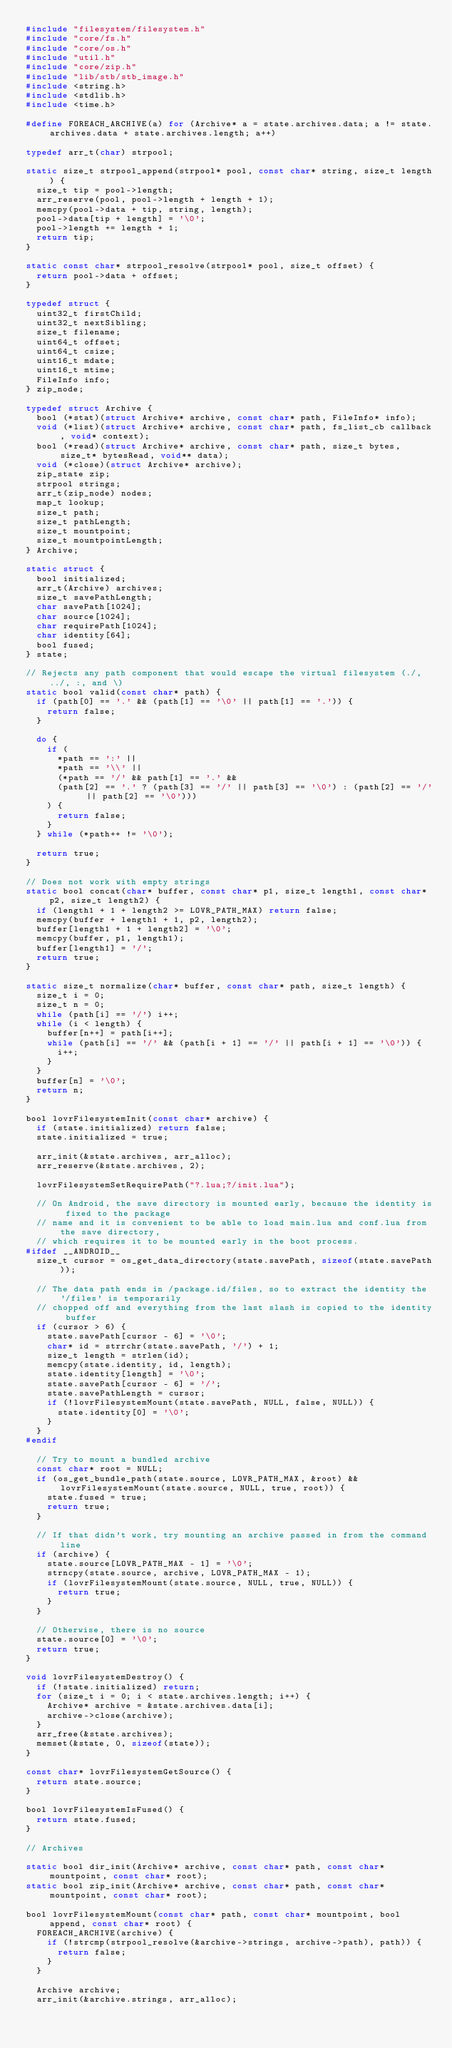<code> <loc_0><loc_0><loc_500><loc_500><_C_>#include "filesystem/filesystem.h"
#include "core/fs.h"
#include "core/os.h"
#include "util.h"
#include "core/zip.h"
#include "lib/stb/stb_image.h"
#include <string.h>
#include <stdlib.h>
#include <time.h>

#define FOREACH_ARCHIVE(a) for (Archive* a = state.archives.data; a != state.archives.data + state.archives.length; a++)

typedef arr_t(char) strpool;

static size_t strpool_append(strpool* pool, const char* string, size_t length) {
  size_t tip = pool->length;
  arr_reserve(pool, pool->length + length + 1);
  memcpy(pool->data + tip, string, length);
  pool->data[tip + length] = '\0';
  pool->length += length + 1;
  return tip;
}

static const char* strpool_resolve(strpool* pool, size_t offset) {
  return pool->data + offset;
}

typedef struct {
  uint32_t firstChild;
  uint32_t nextSibling;
  size_t filename;
  uint64_t offset;
  uint64_t csize;
  uint16_t mdate;
  uint16_t mtime;
  FileInfo info;
} zip_node;

typedef struct Archive {
  bool (*stat)(struct Archive* archive, const char* path, FileInfo* info);
  void (*list)(struct Archive* archive, const char* path, fs_list_cb callback, void* context);
  bool (*read)(struct Archive* archive, const char* path, size_t bytes, size_t* bytesRead, void** data);
  void (*close)(struct Archive* archive);
  zip_state zip;
  strpool strings;
  arr_t(zip_node) nodes;
  map_t lookup;
  size_t path;
  size_t pathLength;
  size_t mountpoint;
  size_t mountpointLength;
} Archive;

static struct {
  bool initialized;
  arr_t(Archive) archives;
  size_t savePathLength;
  char savePath[1024];
  char source[1024];
  char requirePath[1024];
  char identity[64];
  bool fused;
} state;

// Rejects any path component that would escape the virtual filesystem (./, ../, :, and \)
static bool valid(const char* path) {
  if (path[0] == '.' && (path[1] == '\0' || path[1] == '.')) {
    return false;
  }

  do {
    if (
      *path == ':' ||
      *path == '\\' ||
      (*path == '/' && path[1] == '.' &&
      (path[2] == '.' ? (path[3] == '/' || path[3] == '\0') : (path[2] == '/' || path[2] == '\0')))
    ) {
      return false;
    }
  } while (*path++ != '\0');

  return true;
}

// Does not work with empty strings
static bool concat(char* buffer, const char* p1, size_t length1, const char* p2, size_t length2) {
  if (length1 + 1 + length2 >= LOVR_PATH_MAX) return false;
  memcpy(buffer + length1 + 1, p2, length2);
  buffer[length1 + 1 + length2] = '\0';
  memcpy(buffer, p1, length1);
  buffer[length1] = '/';
  return true;
}

static size_t normalize(char* buffer, const char* path, size_t length) {
  size_t i = 0;
  size_t n = 0;
  while (path[i] == '/') i++;
  while (i < length) {
    buffer[n++] = path[i++];
    while (path[i] == '/' && (path[i + 1] == '/' || path[i + 1] == '\0')) {
      i++;
    }
  }
  buffer[n] = '\0';
  return n;
}

bool lovrFilesystemInit(const char* archive) {
  if (state.initialized) return false;
  state.initialized = true;

  arr_init(&state.archives, arr_alloc);
  arr_reserve(&state.archives, 2);

  lovrFilesystemSetRequirePath("?.lua;?/init.lua");

  // On Android, the save directory is mounted early, because the identity is fixed to the package
  // name and it is convenient to be able to load main.lua and conf.lua from the save directory,
  // which requires it to be mounted early in the boot process.
#ifdef __ANDROID__
  size_t cursor = os_get_data_directory(state.savePath, sizeof(state.savePath));

  // The data path ends in /package.id/files, so to extract the identity the '/files' is temporarily
  // chopped off and everything from the last slash is copied to the identity buffer
  if (cursor > 6) {
    state.savePath[cursor - 6] = '\0';
    char* id = strrchr(state.savePath, '/') + 1;
    size_t length = strlen(id);
    memcpy(state.identity, id, length);
    state.identity[length] = '\0';
    state.savePath[cursor - 6] = '/';
    state.savePathLength = cursor;
    if (!lovrFilesystemMount(state.savePath, NULL, false, NULL)) {
      state.identity[0] = '\0';
    }
  }
#endif

  // Try to mount a bundled archive
  const char* root = NULL;
  if (os_get_bundle_path(state.source, LOVR_PATH_MAX, &root) && lovrFilesystemMount(state.source, NULL, true, root)) {
    state.fused = true;
    return true;
  }

  // If that didn't work, try mounting an archive passed in from the command line
  if (archive) {
    state.source[LOVR_PATH_MAX - 1] = '\0';
    strncpy(state.source, archive, LOVR_PATH_MAX - 1);
    if (lovrFilesystemMount(state.source, NULL, true, NULL)) {
      return true;
    }
  }

  // Otherwise, there is no source
  state.source[0] = '\0';
  return true;
}

void lovrFilesystemDestroy() {
  if (!state.initialized) return;
  for (size_t i = 0; i < state.archives.length; i++) {
    Archive* archive = &state.archives.data[i];
    archive->close(archive);
  }
  arr_free(&state.archives);
  memset(&state, 0, sizeof(state));
}

const char* lovrFilesystemGetSource() {
  return state.source;
}

bool lovrFilesystemIsFused() {
  return state.fused;
}

// Archives

static bool dir_init(Archive* archive, const char* path, const char* mountpoint, const char* root);
static bool zip_init(Archive* archive, const char* path, const char* mountpoint, const char* root);

bool lovrFilesystemMount(const char* path, const char* mountpoint, bool append, const char* root) {
  FOREACH_ARCHIVE(archive) {
    if (!strcmp(strpool_resolve(&archive->strings, archive->path), path)) {
      return false;
    }
  }

  Archive archive;
  arr_init(&archive.strings, arr_alloc);
</code> 